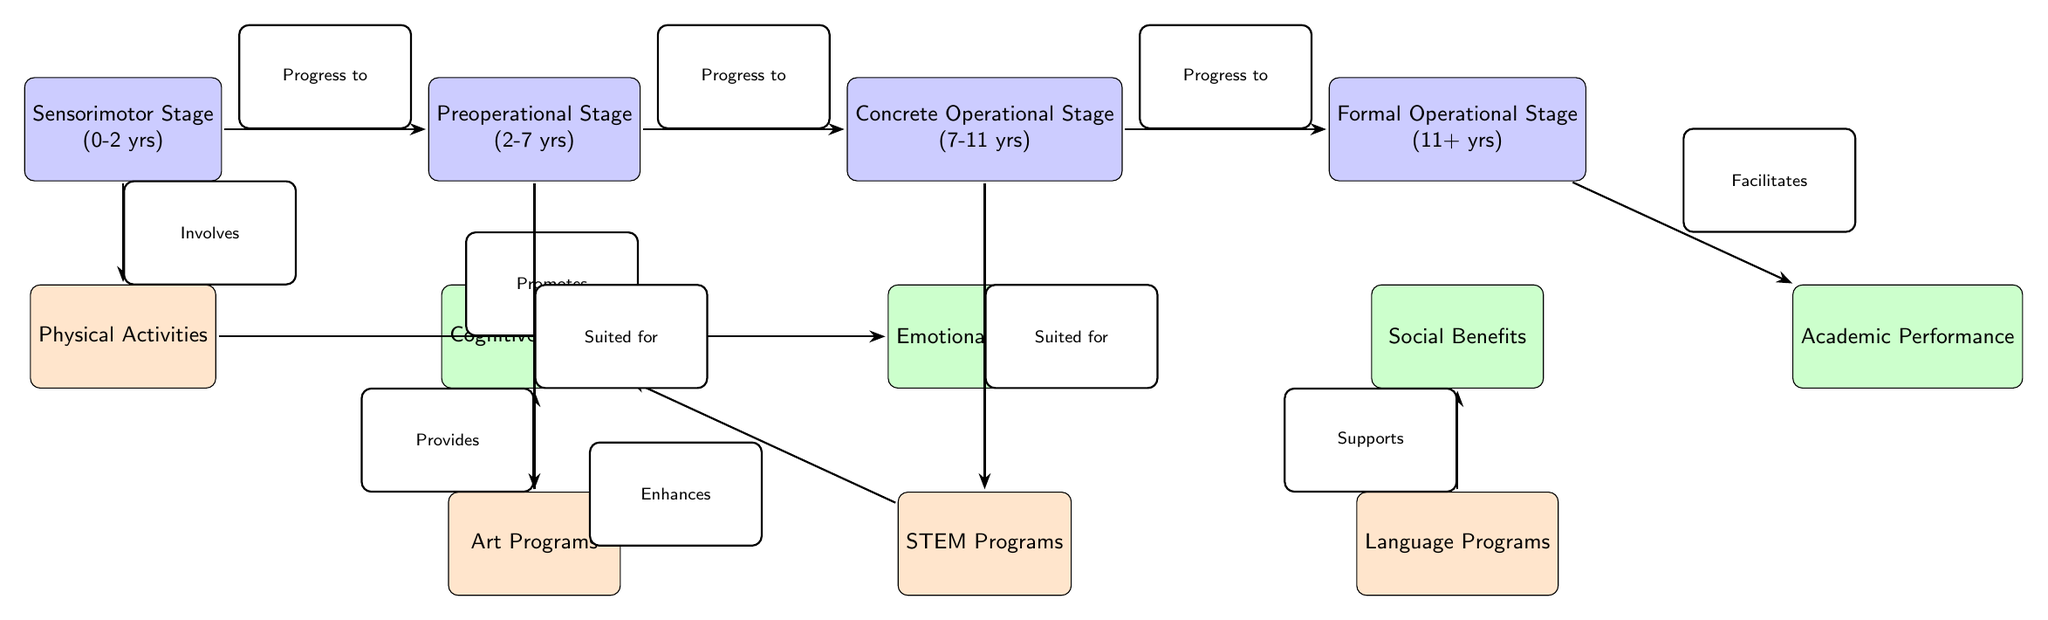What's the age range for the Sensorimotor Stage? The diagram indicates that the Sensorimotor Stage corresponds to the age range of 0 to 2 years, which is stated directly in the node for that stage.
Answer: 0-2 yrs How many stages of cognitive development are there in the diagram? The diagram shows a total of four stages, as represented by the four nodes labeled with distinct stages: Sensorimotor, Preoperational, Concrete Operational, and Formal Operational.
Answer: 4 Which program is suited for the Preoperational Stage? The diagram shows an arrow from the Preoperational Stage node pointing towards the Art Programs node, indicating that art programs are suited for children in this stage.
Answer: Art Programs What benefits are associated with the Concrete Operational Stage? The diagram connects the Concrete Operational Stage to the Emotional Benefits node directly below it, indicating that this stage provides emotional benefits.
Answer: Emotional Benefits What is the relationship between the Formal Operational Stage and Academic Performance? The diagram features an arrow from the Formal Operational Stage to the Academic Performance node, indicating that progress to the formal operational stage facilitates improved academic performance.
Answer: Facilitates Which type of programs enhances cognitive benefits according to the diagram? The diagram shows arrows from both Art Programs and STEM Programs connected to the Cognitive Benefits node, indicating that both types of programs enhance cognitive benefits for children in the relevant stages.
Answer: Art Programs, STEM Programs What type of program is indicated to promote emotional benefits? The diagram contains an arrow from the Physical Activities node that points to the Emotional Benefits node, demonstrating that physical activities promote emotional benefits.
Answer: Physical Activities What stage is associated with Language Programs in the diagram? The arrow pointing towards the Language Programs node is linked to the Social Benefits node, which in turn connects back to the Formal Operational Stage. This indicates that language programs are suitable at the formal operation stage concerning social benefits.
Answer: Formal Operational Stage 